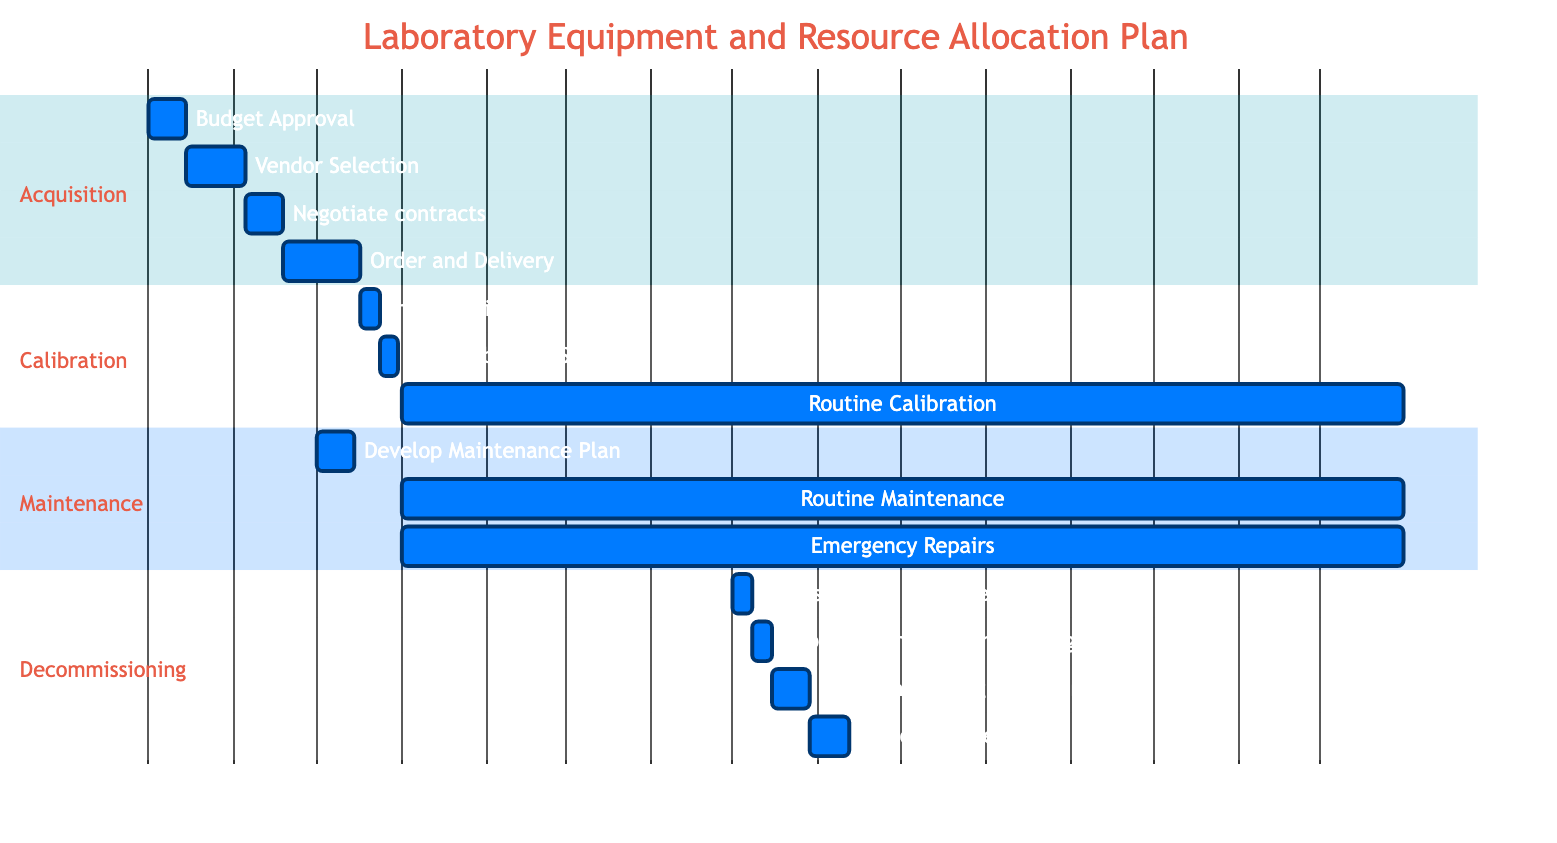What is the duration of the "Vendor Selection" task? The "Vendor Selection" task has a specified duration of 3 weeks, indicated next to the task in the diagram.
Answer: 3 weeks When does the "Initial Calibration" start? The "Initial Calibration" task starts immediately after the completion of "Order and Delivery," which ends on December 16, 2023. Therefore, "Initial Calibration" starts on December 17, 2023.
Answer: December 17, 2023 How many tasks are there in the "Decommissioning" section? In the "Decommissioning" section, there are four tasks listed: "Assessment of Equipment," "Approval for Decommissioning," "Decommissioning Procedures," and "Disposal or Recycling." Counting these gives a total of four tasks.
Answer: 4 What is the sequence of tasks leading to "Disposal or Recycling"? The sequence starts with "Assessment of Equipment," followed by "Approval for Decommissioning," then "Decommissioning Procedures," and finally ends with "Disposal or Recycling." Each task follows sequentially after the previous task's completion.
Answer: Assessment of Equipment, Approval for Decommissioning, Decommissioning Procedures, Disposal or Recycling At what interval is "Routine Calibration" scheduled? "Routine Calibration" is indicated as an ongoing task with a specified interval of quarterly throughout the year 2024, from January 1 to December 31.
Answer: Quarterly 